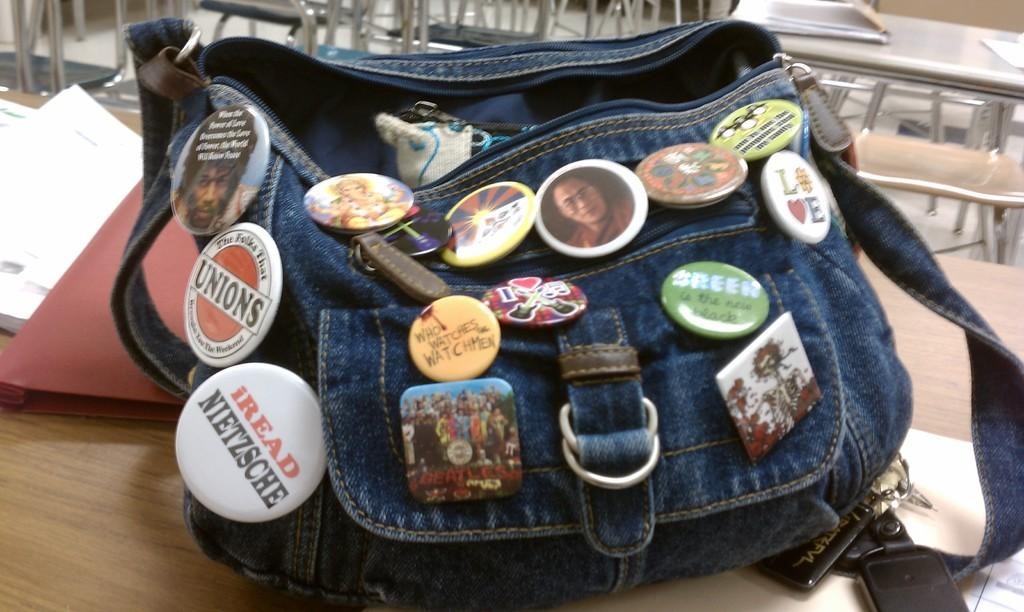What is one of the objects visible in the image? There is a book in the image. What else can be seen on the table in the image? There is a bag with badges in the image. Where are the book and bag located in the image? The book and bag are on a table. What type of linen is being used to cover the book in the image? There is no linen present in the image, nor is the book covered by any fabric. 